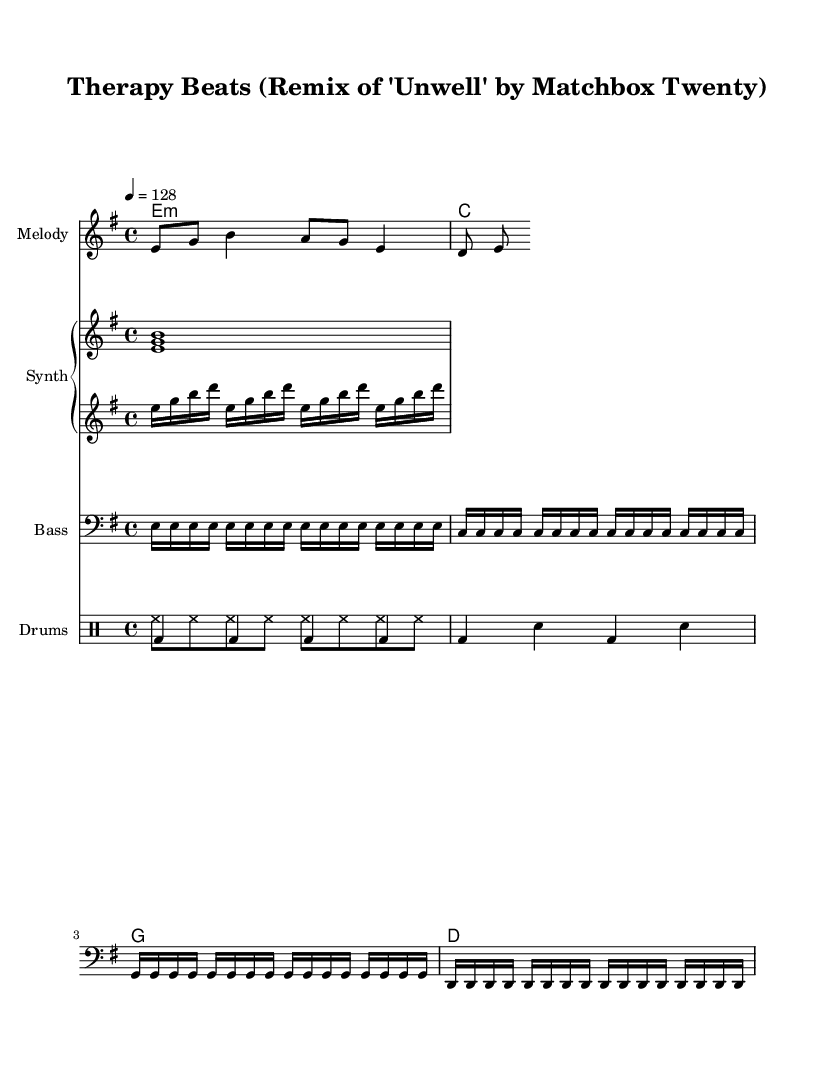What is the key signature of this music? The key signature is E minor, which has one sharp (F#). It can be determined by looking at the first part of the global settings where it specifies `\key e \minor`.
Answer: E minor What is the time signature of this music? The time signature is 4/4, indicating that there are four beats in each measure and the quarter note gets one beat. This is shown in the global settings of the music as `\time 4/4`.
Answer: 4/4 What is the tempo marking in beats per minute? The tempo marking is 128 BPM, as indicated by the `\tempo 4 = 128` directive in the global settings. This means each quarter note is played at 128 beats per minute.
Answer: 128 How many different drum patterns are shown? Two different drum patterns are present: one for the hi-hat and another for the bass drum and snare. This can be identified by looking at the sections labeled `drumsUp` and `drumsDown`, which describe the different rhythms played.
Answer: Two What type of beat does this music predominantly feature? This music predominantly features a four-on-the-floor beat typical of house music, characterized by a bass drum hit on every quarter note, as seen in the `drumsDown` section with bass drum notation.
Answer: Four-on-the-floor How many measures are repeated in the bass section? The bass section repeats four measures, as indicated by the `\repeat unfold 4` directive preceding the bass notes. This shows that the same pattern is played four times without change.
Answer: Four What is the primary chord used in the harmony? The primary chord used in the harmony is E minor, which is the first chord listed in the chord mode section (`e1:m`). This indicates the music's foundational chord structure.
Answer: E minor 